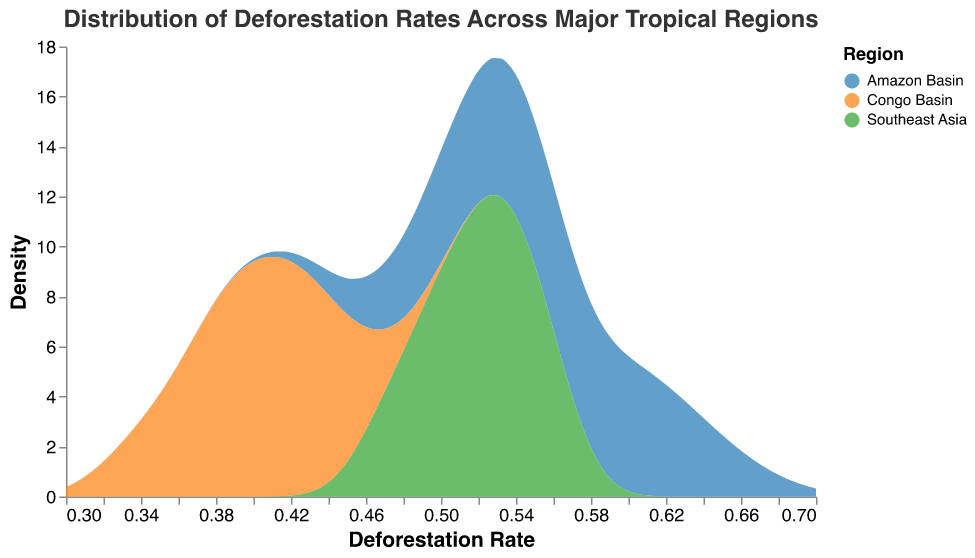What is the title of the density plot? The title is given at the top of the plot, and it describes the main subject of the visualization.
Answer: Distribution of Deforestation Rates Across Major Tropical Regions What are the regions compared in the plot? The regions are listed in the legend with different colors representing each region.
Answer: Amazon Basin, Congo Basin, Southeast Asia What is the range of deforestation rates displayed on the x-axis? The x-axis represents deforestation rates and is labeled accordingly. The axis range can be seen by noting the ticks at the start and end.
Answer: 0.3 to 0.7 Which region has the highest density peak in deforestation rates? The highest density peak can be identified by the tallest area plot among the three regions. This peak will indicate the region with the most frequent or common deforestation rate.
Answer: Amazon Basin What is the range for the density values on the y-axis? The y-axis represents the density of deforestation rates. The range can be found by looking at the smallest and largest tick marks on the y-axis.
Answer: 0 to approximately 9 (precise upper value can depend on the actual plot scale) In which region is the deforestation rate most spread out? To determine the spread of the deforestation rates, look at which region's density plot has the widest base or range. This indicates higher variability in rates.
Answer: Amazon Basin Compare the average deforestation rates between the Amazon Basin and the Congo Basin. To find the average visually, examine the range of density plots and determine the general center of the densities for each region. Compare their central positions.
Answer: The Amazon Basin has a higher average deforestation rate than the Congo Basin Are there any overlapping regions where the deforestation rates of the Amazon Basin and Southeast Asia are similar? Overlapping regions can be identified by looking at the areas where the density plots of the Amazon Basin and Southeast Asia intersect or lie close to each other.
Answer: Yes, around the deforestation rate 0.5 to 0.6 Between the Congo Basin and Southeast Asia, which region shows a higher peak density? Compare the height of the peaks of the density plots for the Congo Basin and Southeast Asia. The taller peak indicates a higher density.
Answer: Southeast Asia Is there a region that has a consistent deforestation rate pattern with a lower density peak? Look for the region with a density plot that has a narrower peak, indicating more consistent, less varied deforestation rates.
Answer: Congo Basin 